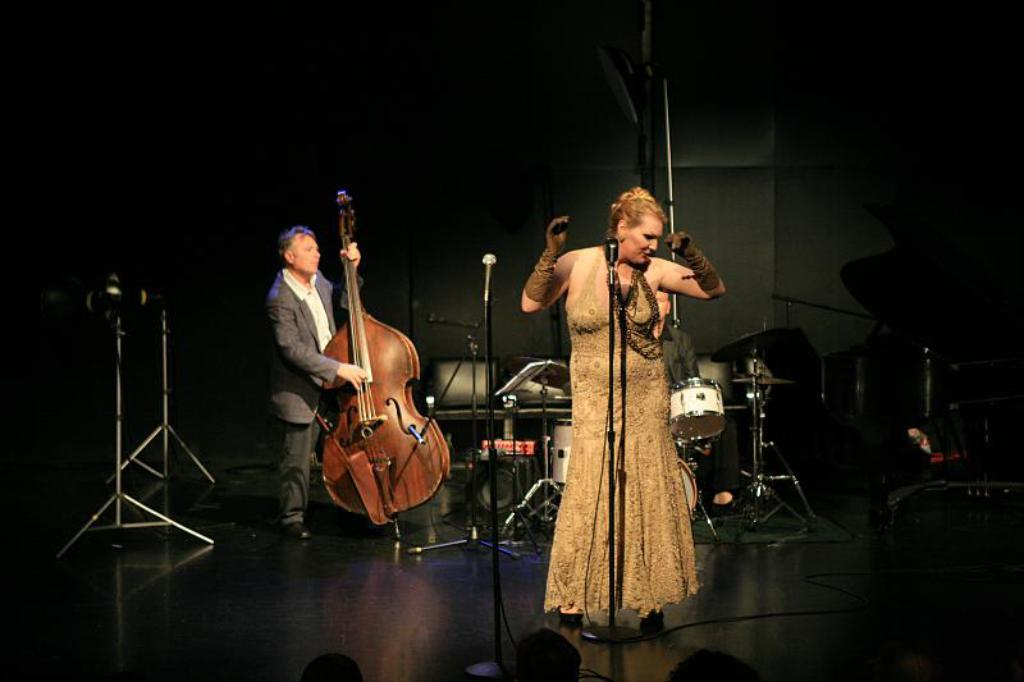What is the woman in the image doing? The woman is singing on a microphone. What is the man in the image doing? The man is holding a guitar. What other objects are present in the image? There are musical instruments in the image. What type of surface is visible in the image? The image shows a floor. What can be seen in the background of the image? There is a wall visible in the background. What is the woman's opinion on the summer season in the image? There is no information about the woman's opinion on the summer season in the image. Is the guitar made of plastic in the image? The image does not provide information about the material of the guitar. 